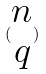Convert formula to latex. <formula><loc_0><loc_0><loc_500><loc_500>( \begin{matrix} n \\ q \end{matrix} )</formula> 